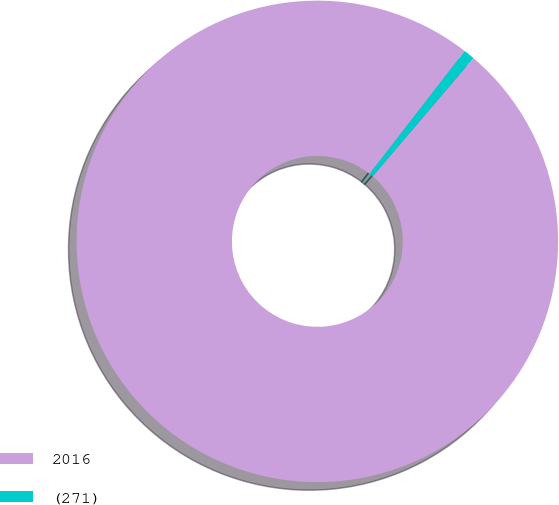Convert chart to OTSL. <chart><loc_0><loc_0><loc_500><loc_500><pie_chart><fcel>2016<fcel>(271)<nl><fcel>99.26%<fcel>0.74%<nl></chart> 